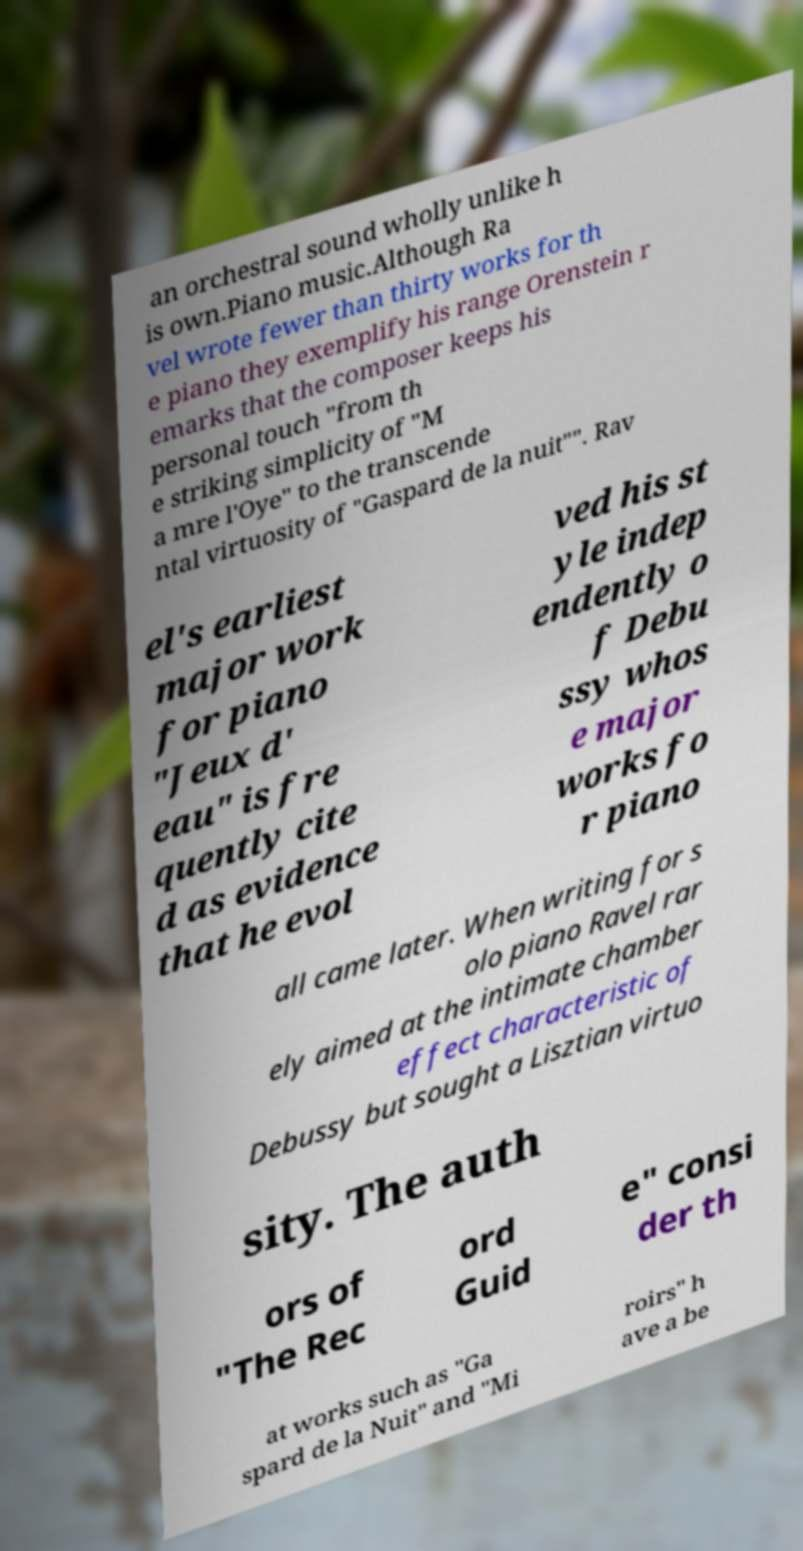Could you assist in decoding the text presented in this image and type it out clearly? an orchestral sound wholly unlike h is own.Piano music.Although Ra vel wrote fewer than thirty works for th e piano they exemplify his range Orenstein r emarks that the composer keeps his personal touch "from th e striking simplicity of "M a mre l'Oye" to the transcende ntal virtuosity of "Gaspard de la nuit"". Rav el's earliest major work for piano "Jeux d' eau" is fre quently cite d as evidence that he evol ved his st yle indep endently o f Debu ssy whos e major works fo r piano all came later. When writing for s olo piano Ravel rar ely aimed at the intimate chamber effect characteristic of Debussy but sought a Lisztian virtuo sity. The auth ors of "The Rec ord Guid e" consi der th at works such as "Ga spard de la Nuit" and "Mi roirs" h ave a be 